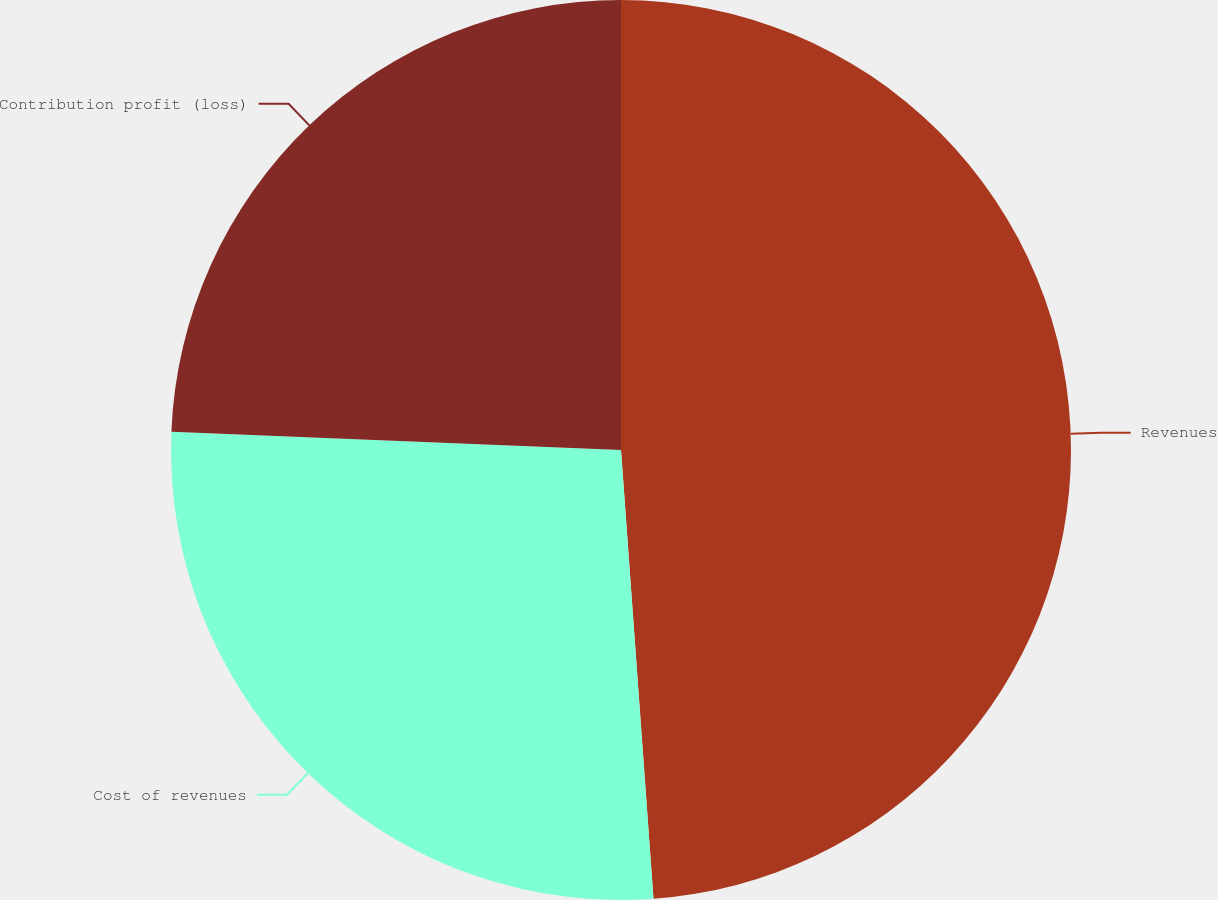<chart> <loc_0><loc_0><loc_500><loc_500><pie_chart><fcel>Revenues<fcel>Cost of revenues<fcel>Contribution profit (loss)<nl><fcel>48.85%<fcel>26.8%<fcel>24.35%<nl></chart> 